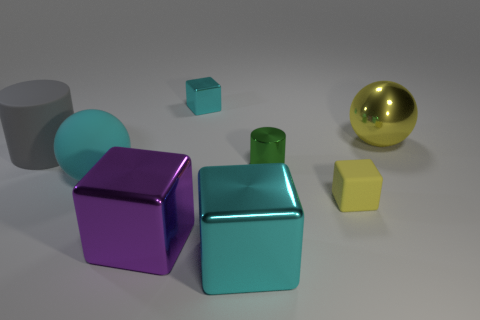There is a ball that is on the right side of the cyan rubber thing; is its size the same as the cyan cube that is behind the rubber cylinder?
Offer a terse response. No. What is the size of the sphere to the left of the tiny cyan shiny thing?
Provide a succinct answer. Large. What number of things are either things that are to the left of the green shiny cylinder or shiny things that are in front of the small green metallic cylinder?
Keep it short and to the point. 5. Is there any other thing that is the same color as the small metal cube?
Keep it short and to the point. Yes. Are there the same number of big yellow things that are in front of the large rubber cylinder and big matte objects that are to the right of the yellow block?
Offer a terse response. Yes. Is the number of cyan matte spheres on the right side of the big purple shiny thing greater than the number of cyan objects?
Ensure brevity in your answer.  No. What number of objects are either objects that are right of the small yellow thing or cyan matte cubes?
Provide a short and direct response. 1. What number of cyan cubes have the same material as the small green thing?
Keep it short and to the point. 2. The other object that is the same color as the small rubber object is what shape?
Your answer should be compact. Sphere. Are there any other large things of the same shape as the purple metal object?
Keep it short and to the point. Yes. 